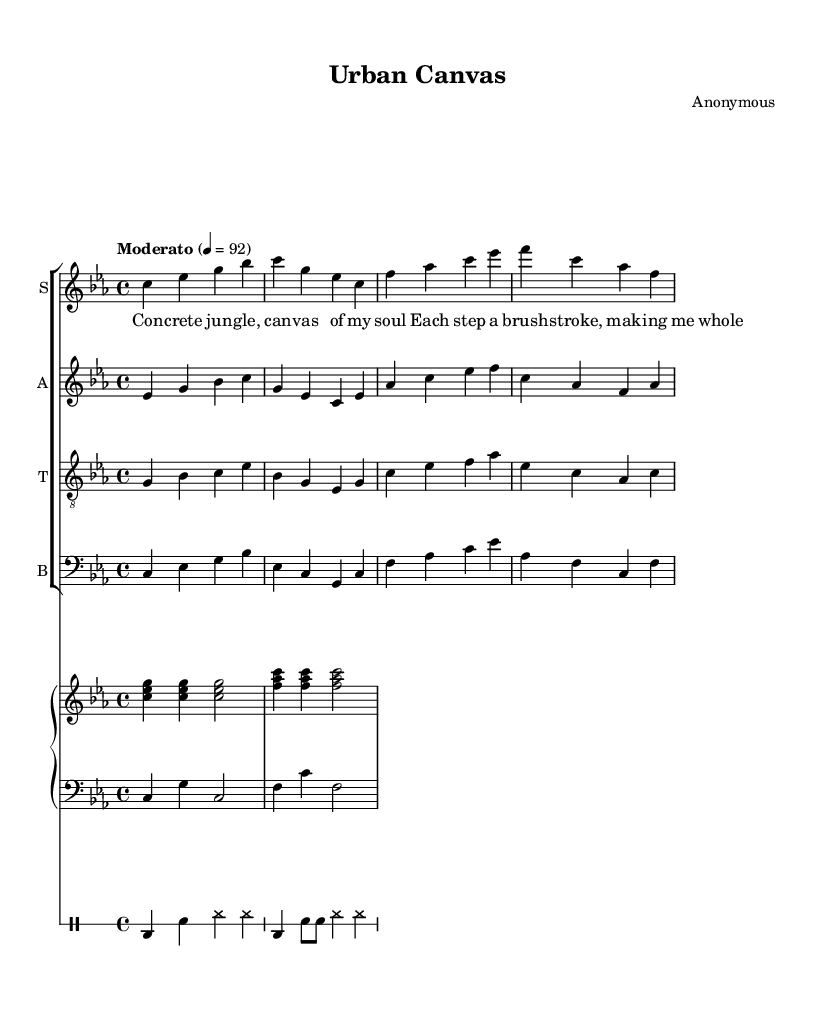What is the key signature of this music? The key signature is indicated at the beginning of the staff. It shows three flats, which correspond to C minor.
Answer: C minor What is the time signature of the piece? The time signature is written after the key signature and indicates the rhythmic structure. This sheet shows 4/4, which means there are four beats per measure.
Answer: 4/4 What is the tempo marking for this music? The tempo marking appears above the staff and indicates the speed of the piece. It states "Moderato," which generally refers to a moderate pace.
Answer: Moderato How many vocal parts are there in this opera? The number of vocal parts is shown by the different staffs labeled S, A, T, and B for soprano, alto, tenor, and bass respectively. Therefore, there are four vocal parts.
Answer: Four What is the title of this opera? The title of the opera is listed at the beginning in the header section, providing the name of the composition.
Answer: Urban Canvas Which instrument plays the lower piano part? The lower piano part is represented with the bass clef, which is typically associated with the lower range of piano tones.
Answer: Bass What theme does the verse of this piece express? The lyrics convey a theme of individuality and self-expression, which aligns with the overall concept of minimalism in an urban context. The visual information in the lyrics suggests an artistic representation of personal experiences in an urban environment.
Answer: Individuality and self-expression 